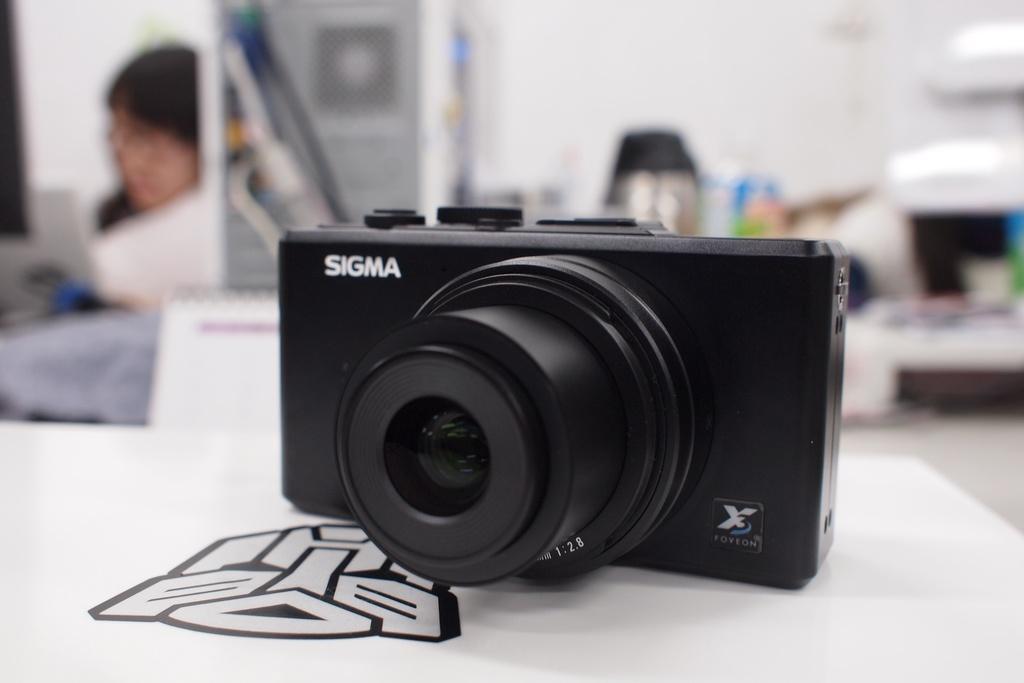Could you give a brief overview of what you see in this image? As we can see in the image there is a white color wall and table. On table there is a camera. On the left side there is a woman wearing white color dress and the background is little blurry. 